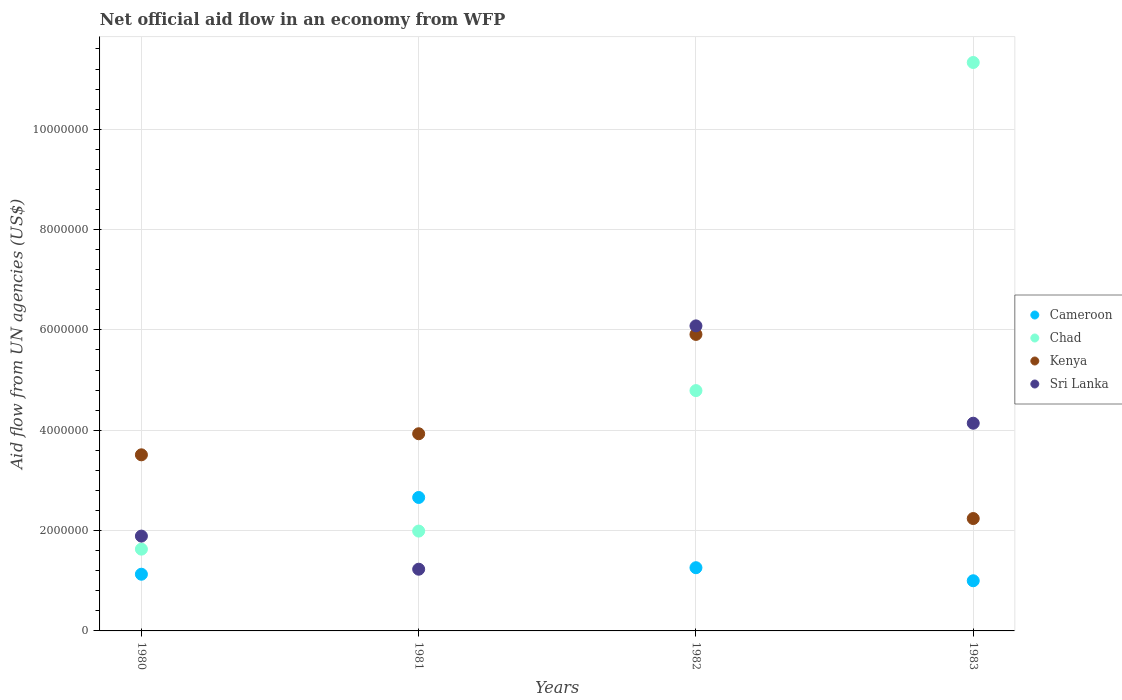How many different coloured dotlines are there?
Make the answer very short. 4. What is the net official aid flow in Kenya in 1981?
Keep it short and to the point. 3.93e+06. Across all years, what is the maximum net official aid flow in Kenya?
Your answer should be compact. 5.91e+06. Across all years, what is the minimum net official aid flow in Chad?
Your answer should be compact. 1.63e+06. What is the total net official aid flow in Sri Lanka in the graph?
Your answer should be very brief. 1.33e+07. What is the difference between the net official aid flow in Chad in 1980 and that in 1981?
Give a very brief answer. -3.60e+05. What is the difference between the net official aid flow in Chad in 1983 and the net official aid flow in Cameroon in 1981?
Ensure brevity in your answer.  8.67e+06. What is the average net official aid flow in Kenya per year?
Make the answer very short. 3.90e+06. In the year 1980, what is the difference between the net official aid flow in Cameroon and net official aid flow in Kenya?
Give a very brief answer. -2.38e+06. In how many years, is the net official aid flow in Cameroon greater than 9200000 US$?
Provide a succinct answer. 0. What is the ratio of the net official aid flow in Sri Lanka in 1982 to that in 1983?
Your answer should be very brief. 1.47. Is the difference between the net official aid flow in Cameroon in 1981 and 1982 greater than the difference between the net official aid flow in Kenya in 1981 and 1982?
Your response must be concise. Yes. What is the difference between the highest and the second highest net official aid flow in Cameroon?
Offer a terse response. 1.40e+06. What is the difference between the highest and the lowest net official aid flow in Chad?
Offer a very short reply. 9.70e+06. Is the sum of the net official aid flow in Kenya in 1980 and 1981 greater than the maximum net official aid flow in Chad across all years?
Ensure brevity in your answer.  No. Is it the case that in every year, the sum of the net official aid flow in Chad and net official aid flow in Sri Lanka  is greater than the sum of net official aid flow in Cameroon and net official aid flow in Kenya?
Provide a short and direct response. No. Is the net official aid flow in Sri Lanka strictly greater than the net official aid flow in Cameroon over the years?
Your response must be concise. No. Is the net official aid flow in Kenya strictly less than the net official aid flow in Chad over the years?
Provide a short and direct response. No. How many dotlines are there?
Provide a short and direct response. 4. How many years are there in the graph?
Your answer should be very brief. 4. What is the difference between two consecutive major ticks on the Y-axis?
Offer a very short reply. 2.00e+06. Does the graph contain any zero values?
Offer a terse response. No. Does the graph contain grids?
Make the answer very short. Yes. Where does the legend appear in the graph?
Give a very brief answer. Center right. How many legend labels are there?
Keep it short and to the point. 4. What is the title of the graph?
Offer a very short reply. Net official aid flow in an economy from WFP. Does "El Salvador" appear as one of the legend labels in the graph?
Keep it short and to the point. No. What is the label or title of the X-axis?
Your answer should be very brief. Years. What is the label or title of the Y-axis?
Ensure brevity in your answer.  Aid flow from UN agencies (US$). What is the Aid flow from UN agencies (US$) in Cameroon in 1980?
Keep it short and to the point. 1.13e+06. What is the Aid flow from UN agencies (US$) of Chad in 1980?
Give a very brief answer. 1.63e+06. What is the Aid flow from UN agencies (US$) of Kenya in 1980?
Offer a very short reply. 3.51e+06. What is the Aid flow from UN agencies (US$) in Sri Lanka in 1980?
Offer a very short reply. 1.89e+06. What is the Aid flow from UN agencies (US$) in Cameroon in 1981?
Provide a succinct answer. 2.66e+06. What is the Aid flow from UN agencies (US$) in Chad in 1981?
Your answer should be very brief. 1.99e+06. What is the Aid flow from UN agencies (US$) of Kenya in 1981?
Provide a short and direct response. 3.93e+06. What is the Aid flow from UN agencies (US$) of Sri Lanka in 1981?
Provide a short and direct response. 1.23e+06. What is the Aid flow from UN agencies (US$) of Cameroon in 1982?
Keep it short and to the point. 1.26e+06. What is the Aid flow from UN agencies (US$) of Chad in 1982?
Provide a succinct answer. 4.79e+06. What is the Aid flow from UN agencies (US$) of Kenya in 1982?
Provide a succinct answer. 5.91e+06. What is the Aid flow from UN agencies (US$) in Sri Lanka in 1982?
Offer a terse response. 6.08e+06. What is the Aid flow from UN agencies (US$) in Chad in 1983?
Provide a short and direct response. 1.13e+07. What is the Aid flow from UN agencies (US$) of Kenya in 1983?
Provide a short and direct response. 2.24e+06. What is the Aid flow from UN agencies (US$) in Sri Lanka in 1983?
Provide a succinct answer. 4.14e+06. Across all years, what is the maximum Aid flow from UN agencies (US$) in Cameroon?
Keep it short and to the point. 2.66e+06. Across all years, what is the maximum Aid flow from UN agencies (US$) of Chad?
Your answer should be very brief. 1.13e+07. Across all years, what is the maximum Aid flow from UN agencies (US$) in Kenya?
Offer a terse response. 5.91e+06. Across all years, what is the maximum Aid flow from UN agencies (US$) in Sri Lanka?
Offer a terse response. 6.08e+06. Across all years, what is the minimum Aid flow from UN agencies (US$) in Cameroon?
Give a very brief answer. 1.00e+06. Across all years, what is the minimum Aid flow from UN agencies (US$) of Chad?
Your answer should be very brief. 1.63e+06. Across all years, what is the minimum Aid flow from UN agencies (US$) of Kenya?
Offer a terse response. 2.24e+06. Across all years, what is the minimum Aid flow from UN agencies (US$) in Sri Lanka?
Your answer should be very brief. 1.23e+06. What is the total Aid flow from UN agencies (US$) of Cameroon in the graph?
Give a very brief answer. 6.05e+06. What is the total Aid flow from UN agencies (US$) of Chad in the graph?
Make the answer very short. 1.97e+07. What is the total Aid flow from UN agencies (US$) of Kenya in the graph?
Keep it short and to the point. 1.56e+07. What is the total Aid flow from UN agencies (US$) in Sri Lanka in the graph?
Your answer should be very brief. 1.33e+07. What is the difference between the Aid flow from UN agencies (US$) of Cameroon in 1980 and that in 1981?
Ensure brevity in your answer.  -1.53e+06. What is the difference between the Aid flow from UN agencies (US$) in Chad in 1980 and that in 1981?
Ensure brevity in your answer.  -3.60e+05. What is the difference between the Aid flow from UN agencies (US$) in Kenya in 1980 and that in 1981?
Offer a terse response. -4.20e+05. What is the difference between the Aid flow from UN agencies (US$) in Sri Lanka in 1980 and that in 1981?
Your response must be concise. 6.60e+05. What is the difference between the Aid flow from UN agencies (US$) in Cameroon in 1980 and that in 1982?
Make the answer very short. -1.30e+05. What is the difference between the Aid flow from UN agencies (US$) of Chad in 1980 and that in 1982?
Make the answer very short. -3.16e+06. What is the difference between the Aid flow from UN agencies (US$) in Kenya in 1980 and that in 1982?
Your answer should be very brief. -2.40e+06. What is the difference between the Aid flow from UN agencies (US$) of Sri Lanka in 1980 and that in 1982?
Provide a short and direct response. -4.19e+06. What is the difference between the Aid flow from UN agencies (US$) of Chad in 1980 and that in 1983?
Give a very brief answer. -9.70e+06. What is the difference between the Aid flow from UN agencies (US$) in Kenya in 1980 and that in 1983?
Give a very brief answer. 1.27e+06. What is the difference between the Aid flow from UN agencies (US$) of Sri Lanka in 1980 and that in 1983?
Your answer should be compact. -2.25e+06. What is the difference between the Aid flow from UN agencies (US$) of Cameroon in 1981 and that in 1982?
Your response must be concise. 1.40e+06. What is the difference between the Aid flow from UN agencies (US$) in Chad in 1981 and that in 1982?
Your answer should be very brief. -2.80e+06. What is the difference between the Aid flow from UN agencies (US$) in Kenya in 1981 and that in 1982?
Offer a very short reply. -1.98e+06. What is the difference between the Aid flow from UN agencies (US$) in Sri Lanka in 1981 and that in 1982?
Make the answer very short. -4.85e+06. What is the difference between the Aid flow from UN agencies (US$) in Cameroon in 1981 and that in 1983?
Give a very brief answer. 1.66e+06. What is the difference between the Aid flow from UN agencies (US$) in Chad in 1981 and that in 1983?
Give a very brief answer. -9.34e+06. What is the difference between the Aid flow from UN agencies (US$) in Kenya in 1981 and that in 1983?
Give a very brief answer. 1.69e+06. What is the difference between the Aid flow from UN agencies (US$) in Sri Lanka in 1981 and that in 1983?
Give a very brief answer. -2.91e+06. What is the difference between the Aid flow from UN agencies (US$) of Cameroon in 1982 and that in 1983?
Your answer should be very brief. 2.60e+05. What is the difference between the Aid flow from UN agencies (US$) in Chad in 1982 and that in 1983?
Keep it short and to the point. -6.54e+06. What is the difference between the Aid flow from UN agencies (US$) of Kenya in 1982 and that in 1983?
Ensure brevity in your answer.  3.67e+06. What is the difference between the Aid flow from UN agencies (US$) of Sri Lanka in 1982 and that in 1983?
Provide a short and direct response. 1.94e+06. What is the difference between the Aid flow from UN agencies (US$) in Cameroon in 1980 and the Aid flow from UN agencies (US$) in Chad in 1981?
Offer a terse response. -8.60e+05. What is the difference between the Aid flow from UN agencies (US$) of Cameroon in 1980 and the Aid flow from UN agencies (US$) of Kenya in 1981?
Provide a short and direct response. -2.80e+06. What is the difference between the Aid flow from UN agencies (US$) of Chad in 1980 and the Aid flow from UN agencies (US$) of Kenya in 1981?
Your answer should be compact. -2.30e+06. What is the difference between the Aid flow from UN agencies (US$) of Chad in 1980 and the Aid flow from UN agencies (US$) of Sri Lanka in 1981?
Your answer should be compact. 4.00e+05. What is the difference between the Aid flow from UN agencies (US$) of Kenya in 1980 and the Aid flow from UN agencies (US$) of Sri Lanka in 1981?
Give a very brief answer. 2.28e+06. What is the difference between the Aid flow from UN agencies (US$) of Cameroon in 1980 and the Aid flow from UN agencies (US$) of Chad in 1982?
Offer a very short reply. -3.66e+06. What is the difference between the Aid flow from UN agencies (US$) in Cameroon in 1980 and the Aid flow from UN agencies (US$) in Kenya in 1982?
Keep it short and to the point. -4.78e+06. What is the difference between the Aid flow from UN agencies (US$) in Cameroon in 1980 and the Aid flow from UN agencies (US$) in Sri Lanka in 1982?
Your answer should be very brief. -4.95e+06. What is the difference between the Aid flow from UN agencies (US$) of Chad in 1980 and the Aid flow from UN agencies (US$) of Kenya in 1982?
Offer a terse response. -4.28e+06. What is the difference between the Aid flow from UN agencies (US$) of Chad in 1980 and the Aid flow from UN agencies (US$) of Sri Lanka in 1982?
Your response must be concise. -4.45e+06. What is the difference between the Aid flow from UN agencies (US$) of Kenya in 1980 and the Aid flow from UN agencies (US$) of Sri Lanka in 1982?
Your answer should be very brief. -2.57e+06. What is the difference between the Aid flow from UN agencies (US$) of Cameroon in 1980 and the Aid flow from UN agencies (US$) of Chad in 1983?
Your response must be concise. -1.02e+07. What is the difference between the Aid flow from UN agencies (US$) of Cameroon in 1980 and the Aid flow from UN agencies (US$) of Kenya in 1983?
Your answer should be compact. -1.11e+06. What is the difference between the Aid flow from UN agencies (US$) of Cameroon in 1980 and the Aid flow from UN agencies (US$) of Sri Lanka in 1983?
Provide a succinct answer. -3.01e+06. What is the difference between the Aid flow from UN agencies (US$) in Chad in 1980 and the Aid flow from UN agencies (US$) in Kenya in 1983?
Your answer should be very brief. -6.10e+05. What is the difference between the Aid flow from UN agencies (US$) in Chad in 1980 and the Aid flow from UN agencies (US$) in Sri Lanka in 1983?
Your answer should be very brief. -2.51e+06. What is the difference between the Aid flow from UN agencies (US$) of Kenya in 1980 and the Aid flow from UN agencies (US$) of Sri Lanka in 1983?
Your answer should be very brief. -6.30e+05. What is the difference between the Aid flow from UN agencies (US$) in Cameroon in 1981 and the Aid flow from UN agencies (US$) in Chad in 1982?
Ensure brevity in your answer.  -2.13e+06. What is the difference between the Aid flow from UN agencies (US$) of Cameroon in 1981 and the Aid flow from UN agencies (US$) of Kenya in 1982?
Your answer should be compact. -3.25e+06. What is the difference between the Aid flow from UN agencies (US$) of Cameroon in 1981 and the Aid flow from UN agencies (US$) of Sri Lanka in 1982?
Offer a terse response. -3.42e+06. What is the difference between the Aid flow from UN agencies (US$) of Chad in 1981 and the Aid flow from UN agencies (US$) of Kenya in 1982?
Offer a very short reply. -3.92e+06. What is the difference between the Aid flow from UN agencies (US$) in Chad in 1981 and the Aid flow from UN agencies (US$) in Sri Lanka in 1982?
Give a very brief answer. -4.09e+06. What is the difference between the Aid flow from UN agencies (US$) in Kenya in 1981 and the Aid flow from UN agencies (US$) in Sri Lanka in 1982?
Offer a very short reply. -2.15e+06. What is the difference between the Aid flow from UN agencies (US$) in Cameroon in 1981 and the Aid flow from UN agencies (US$) in Chad in 1983?
Keep it short and to the point. -8.67e+06. What is the difference between the Aid flow from UN agencies (US$) of Cameroon in 1981 and the Aid flow from UN agencies (US$) of Kenya in 1983?
Your answer should be very brief. 4.20e+05. What is the difference between the Aid flow from UN agencies (US$) in Cameroon in 1981 and the Aid flow from UN agencies (US$) in Sri Lanka in 1983?
Give a very brief answer. -1.48e+06. What is the difference between the Aid flow from UN agencies (US$) of Chad in 1981 and the Aid flow from UN agencies (US$) of Kenya in 1983?
Your answer should be compact. -2.50e+05. What is the difference between the Aid flow from UN agencies (US$) in Chad in 1981 and the Aid flow from UN agencies (US$) in Sri Lanka in 1983?
Your response must be concise. -2.15e+06. What is the difference between the Aid flow from UN agencies (US$) in Kenya in 1981 and the Aid flow from UN agencies (US$) in Sri Lanka in 1983?
Keep it short and to the point. -2.10e+05. What is the difference between the Aid flow from UN agencies (US$) in Cameroon in 1982 and the Aid flow from UN agencies (US$) in Chad in 1983?
Offer a very short reply. -1.01e+07. What is the difference between the Aid flow from UN agencies (US$) of Cameroon in 1982 and the Aid flow from UN agencies (US$) of Kenya in 1983?
Offer a very short reply. -9.80e+05. What is the difference between the Aid flow from UN agencies (US$) in Cameroon in 1982 and the Aid flow from UN agencies (US$) in Sri Lanka in 1983?
Offer a terse response. -2.88e+06. What is the difference between the Aid flow from UN agencies (US$) of Chad in 1982 and the Aid flow from UN agencies (US$) of Kenya in 1983?
Ensure brevity in your answer.  2.55e+06. What is the difference between the Aid flow from UN agencies (US$) of Chad in 1982 and the Aid flow from UN agencies (US$) of Sri Lanka in 1983?
Offer a terse response. 6.50e+05. What is the difference between the Aid flow from UN agencies (US$) in Kenya in 1982 and the Aid flow from UN agencies (US$) in Sri Lanka in 1983?
Your answer should be compact. 1.77e+06. What is the average Aid flow from UN agencies (US$) of Cameroon per year?
Ensure brevity in your answer.  1.51e+06. What is the average Aid flow from UN agencies (US$) in Chad per year?
Keep it short and to the point. 4.94e+06. What is the average Aid flow from UN agencies (US$) in Kenya per year?
Keep it short and to the point. 3.90e+06. What is the average Aid flow from UN agencies (US$) of Sri Lanka per year?
Your response must be concise. 3.34e+06. In the year 1980, what is the difference between the Aid flow from UN agencies (US$) in Cameroon and Aid flow from UN agencies (US$) in Chad?
Offer a terse response. -5.00e+05. In the year 1980, what is the difference between the Aid flow from UN agencies (US$) of Cameroon and Aid flow from UN agencies (US$) of Kenya?
Your answer should be very brief. -2.38e+06. In the year 1980, what is the difference between the Aid flow from UN agencies (US$) of Cameroon and Aid flow from UN agencies (US$) of Sri Lanka?
Offer a very short reply. -7.60e+05. In the year 1980, what is the difference between the Aid flow from UN agencies (US$) of Chad and Aid flow from UN agencies (US$) of Kenya?
Give a very brief answer. -1.88e+06. In the year 1980, what is the difference between the Aid flow from UN agencies (US$) in Chad and Aid flow from UN agencies (US$) in Sri Lanka?
Give a very brief answer. -2.60e+05. In the year 1980, what is the difference between the Aid flow from UN agencies (US$) in Kenya and Aid flow from UN agencies (US$) in Sri Lanka?
Provide a short and direct response. 1.62e+06. In the year 1981, what is the difference between the Aid flow from UN agencies (US$) of Cameroon and Aid flow from UN agencies (US$) of Chad?
Ensure brevity in your answer.  6.70e+05. In the year 1981, what is the difference between the Aid flow from UN agencies (US$) of Cameroon and Aid flow from UN agencies (US$) of Kenya?
Offer a terse response. -1.27e+06. In the year 1981, what is the difference between the Aid flow from UN agencies (US$) of Cameroon and Aid flow from UN agencies (US$) of Sri Lanka?
Your answer should be compact. 1.43e+06. In the year 1981, what is the difference between the Aid flow from UN agencies (US$) of Chad and Aid flow from UN agencies (US$) of Kenya?
Keep it short and to the point. -1.94e+06. In the year 1981, what is the difference between the Aid flow from UN agencies (US$) in Chad and Aid flow from UN agencies (US$) in Sri Lanka?
Ensure brevity in your answer.  7.60e+05. In the year 1981, what is the difference between the Aid flow from UN agencies (US$) of Kenya and Aid flow from UN agencies (US$) of Sri Lanka?
Provide a short and direct response. 2.70e+06. In the year 1982, what is the difference between the Aid flow from UN agencies (US$) of Cameroon and Aid flow from UN agencies (US$) of Chad?
Ensure brevity in your answer.  -3.53e+06. In the year 1982, what is the difference between the Aid flow from UN agencies (US$) in Cameroon and Aid flow from UN agencies (US$) in Kenya?
Provide a succinct answer. -4.65e+06. In the year 1982, what is the difference between the Aid flow from UN agencies (US$) in Cameroon and Aid flow from UN agencies (US$) in Sri Lanka?
Your answer should be compact. -4.82e+06. In the year 1982, what is the difference between the Aid flow from UN agencies (US$) in Chad and Aid flow from UN agencies (US$) in Kenya?
Make the answer very short. -1.12e+06. In the year 1982, what is the difference between the Aid flow from UN agencies (US$) in Chad and Aid flow from UN agencies (US$) in Sri Lanka?
Offer a very short reply. -1.29e+06. In the year 1982, what is the difference between the Aid flow from UN agencies (US$) of Kenya and Aid flow from UN agencies (US$) of Sri Lanka?
Ensure brevity in your answer.  -1.70e+05. In the year 1983, what is the difference between the Aid flow from UN agencies (US$) in Cameroon and Aid flow from UN agencies (US$) in Chad?
Provide a succinct answer. -1.03e+07. In the year 1983, what is the difference between the Aid flow from UN agencies (US$) of Cameroon and Aid flow from UN agencies (US$) of Kenya?
Provide a succinct answer. -1.24e+06. In the year 1983, what is the difference between the Aid flow from UN agencies (US$) of Cameroon and Aid flow from UN agencies (US$) of Sri Lanka?
Your response must be concise. -3.14e+06. In the year 1983, what is the difference between the Aid flow from UN agencies (US$) in Chad and Aid flow from UN agencies (US$) in Kenya?
Your answer should be very brief. 9.09e+06. In the year 1983, what is the difference between the Aid flow from UN agencies (US$) of Chad and Aid flow from UN agencies (US$) of Sri Lanka?
Give a very brief answer. 7.19e+06. In the year 1983, what is the difference between the Aid flow from UN agencies (US$) in Kenya and Aid flow from UN agencies (US$) in Sri Lanka?
Make the answer very short. -1.90e+06. What is the ratio of the Aid flow from UN agencies (US$) in Cameroon in 1980 to that in 1981?
Your answer should be very brief. 0.42. What is the ratio of the Aid flow from UN agencies (US$) in Chad in 1980 to that in 1981?
Offer a terse response. 0.82. What is the ratio of the Aid flow from UN agencies (US$) of Kenya in 1980 to that in 1981?
Provide a short and direct response. 0.89. What is the ratio of the Aid flow from UN agencies (US$) in Sri Lanka in 1980 to that in 1981?
Offer a terse response. 1.54. What is the ratio of the Aid flow from UN agencies (US$) of Cameroon in 1980 to that in 1982?
Offer a terse response. 0.9. What is the ratio of the Aid flow from UN agencies (US$) in Chad in 1980 to that in 1982?
Keep it short and to the point. 0.34. What is the ratio of the Aid flow from UN agencies (US$) in Kenya in 1980 to that in 1982?
Make the answer very short. 0.59. What is the ratio of the Aid flow from UN agencies (US$) in Sri Lanka in 1980 to that in 1982?
Offer a terse response. 0.31. What is the ratio of the Aid flow from UN agencies (US$) in Cameroon in 1980 to that in 1983?
Offer a terse response. 1.13. What is the ratio of the Aid flow from UN agencies (US$) in Chad in 1980 to that in 1983?
Ensure brevity in your answer.  0.14. What is the ratio of the Aid flow from UN agencies (US$) in Kenya in 1980 to that in 1983?
Ensure brevity in your answer.  1.57. What is the ratio of the Aid flow from UN agencies (US$) in Sri Lanka in 1980 to that in 1983?
Provide a short and direct response. 0.46. What is the ratio of the Aid flow from UN agencies (US$) in Cameroon in 1981 to that in 1982?
Offer a very short reply. 2.11. What is the ratio of the Aid flow from UN agencies (US$) in Chad in 1981 to that in 1982?
Offer a terse response. 0.42. What is the ratio of the Aid flow from UN agencies (US$) in Kenya in 1981 to that in 1982?
Your response must be concise. 0.67. What is the ratio of the Aid flow from UN agencies (US$) in Sri Lanka in 1981 to that in 1982?
Ensure brevity in your answer.  0.2. What is the ratio of the Aid flow from UN agencies (US$) of Cameroon in 1981 to that in 1983?
Provide a short and direct response. 2.66. What is the ratio of the Aid flow from UN agencies (US$) of Chad in 1981 to that in 1983?
Provide a short and direct response. 0.18. What is the ratio of the Aid flow from UN agencies (US$) of Kenya in 1981 to that in 1983?
Offer a terse response. 1.75. What is the ratio of the Aid flow from UN agencies (US$) in Sri Lanka in 1981 to that in 1983?
Your answer should be very brief. 0.3. What is the ratio of the Aid flow from UN agencies (US$) of Cameroon in 1982 to that in 1983?
Provide a short and direct response. 1.26. What is the ratio of the Aid flow from UN agencies (US$) of Chad in 1982 to that in 1983?
Your response must be concise. 0.42. What is the ratio of the Aid flow from UN agencies (US$) in Kenya in 1982 to that in 1983?
Give a very brief answer. 2.64. What is the ratio of the Aid flow from UN agencies (US$) in Sri Lanka in 1982 to that in 1983?
Keep it short and to the point. 1.47. What is the difference between the highest and the second highest Aid flow from UN agencies (US$) in Cameroon?
Provide a short and direct response. 1.40e+06. What is the difference between the highest and the second highest Aid flow from UN agencies (US$) of Chad?
Your answer should be compact. 6.54e+06. What is the difference between the highest and the second highest Aid flow from UN agencies (US$) of Kenya?
Offer a very short reply. 1.98e+06. What is the difference between the highest and the second highest Aid flow from UN agencies (US$) of Sri Lanka?
Give a very brief answer. 1.94e+06. What is the difference between the highest and the lowest Aid flow from UN agencies (US$) in Cameroon?
Make the answer very short. 1.66e+06. What is the difference between the highest and the lowest Aid flow from UN agencies (US$) in Chad?
Your response must be concise. 9.70e+06. What is the difference between the highest and the lowest Aid flow from UN agencies (US$) in Kenya?
Provide a succinct answer. 3.67e+06. What is the difference between the highest and the lowest Aid flow from UN agencies (US$) in Sri Lanka?
Ensure brevity in your answer.  4.85e+06. 